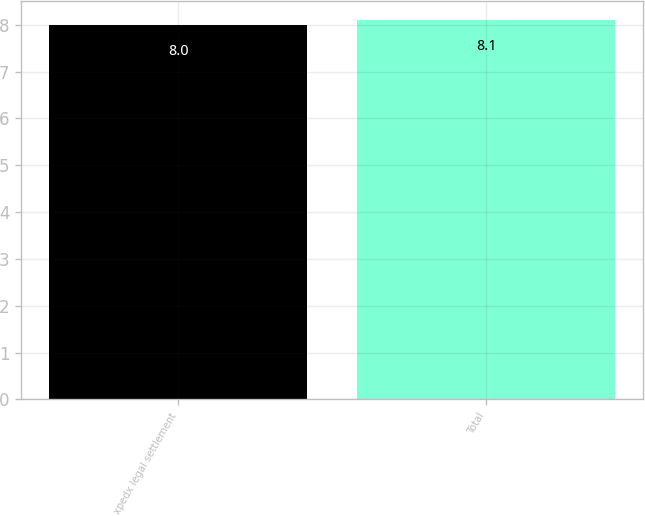Convert chart to OTSL. <chart><loc_0><loc_0><loc_500><loc_500><bar_chart><fcel>xpedx legal settlement<fcel>Total<nl><fcel>8<fcel>8.1<nl></chart> 